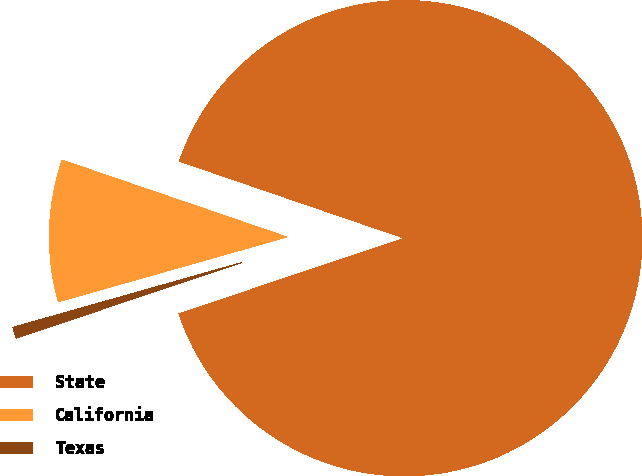Convert chart to OTSL. <chart><loc_0><loc_0><loc_500><loc_500><pie_chart><fcel>State<fcel>California<fcel>Texas<nl><fcel>89.6%<fcel>9.64%<fcel>0.76%<nl></chart> 